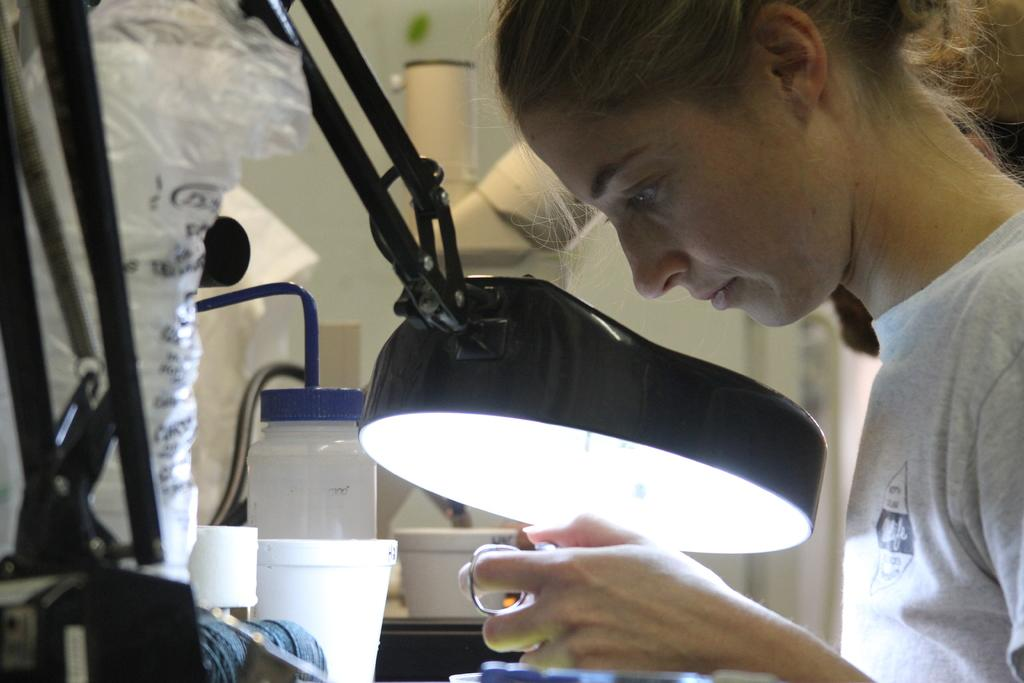Who is the main subject in the image? There is a girl in the image. What is the girl holding in the image? The girl is holding an object. Can you describe any other objects in the image besides the girl and her held object? There is a lamp in the image, as well as other unspecified objects. What color is the coat the girl is wearing in the image? There is no coat present in the image, as the girl is not wearing one. How many bananas can be seen in the image? There are no bananas present in the image. 